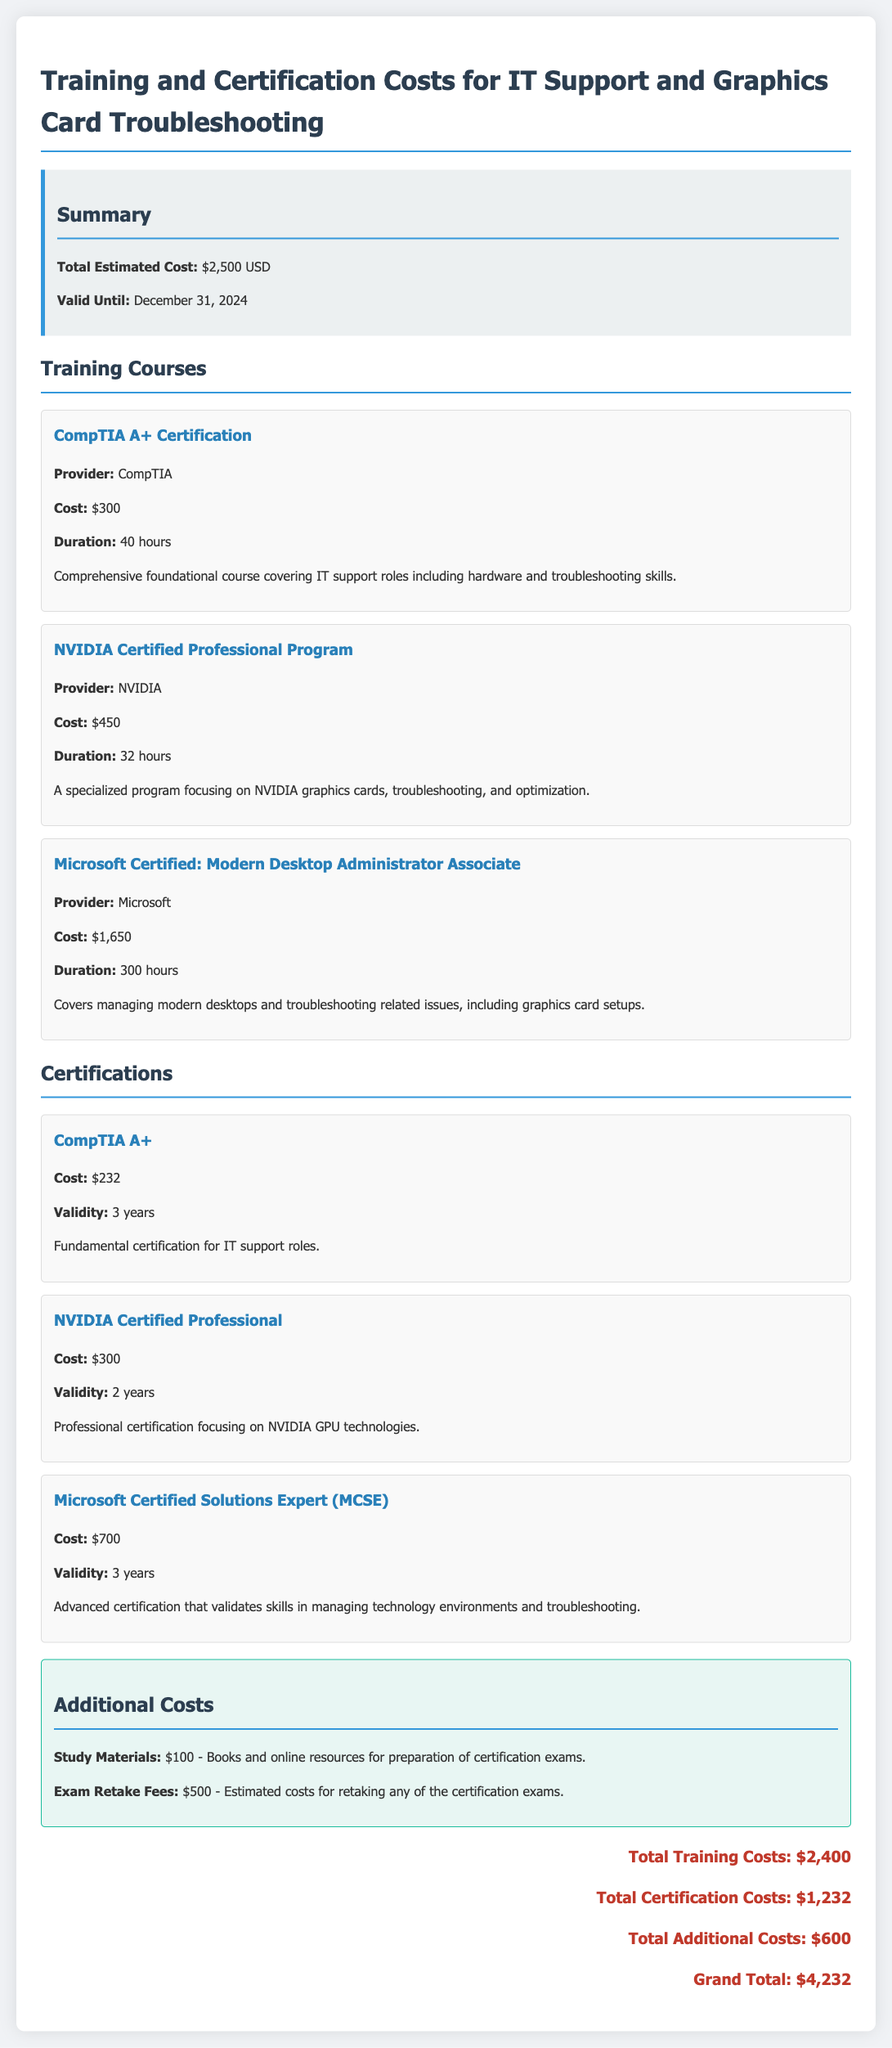What is the total estimated cost? The total estimated cost is explicitly mentioned in the summary section of the document as $2,500 USD.
Answer: $2,500 USD Who provides the CompTIA A+ Certification? The provider of the CompTIA A+ Certification is stated in the training courses section of the document as CompTIA.
Answer: CompTIA How long is the NVIDIA Certified Professional Program? The duration of the NVIDIA Certified Professional Program is mentioned as 32 hours in the training courses section.
Answer: 32 hours What is the validity period of the NVIDIA Certified Professional certification? The validity period for the NVIDIA Certified Professional certification is stated to be 2 years.
Answer: 2 years What are the total additional costs? The total additional costs are summarized in the additional costs section of the document, which lists them as $600.
Answer: $600 What is the cost of the Microsoft Certified Solutions Expert (MCSE)? The cost of the Microsoft Certified Solutions Expert (MCSE) is specified in the certification section as $700.
Answer: $700 What is included in the additional costs? The additional costs section includes study materials and exam retake fees, specifically noting cost amounts for both.
Answer: Study Materials and Exam Retake Fees What is the grand total for training, certification, and additional costs? The grand total combines all costs stated at the bottom of the document, specifically totaling $4,232.
Answer: $4,232 How much does the CompTIA A+ certification cost? The cost of the CompTIA A+ certification is given in the certification section as $232.
Answer: $232 